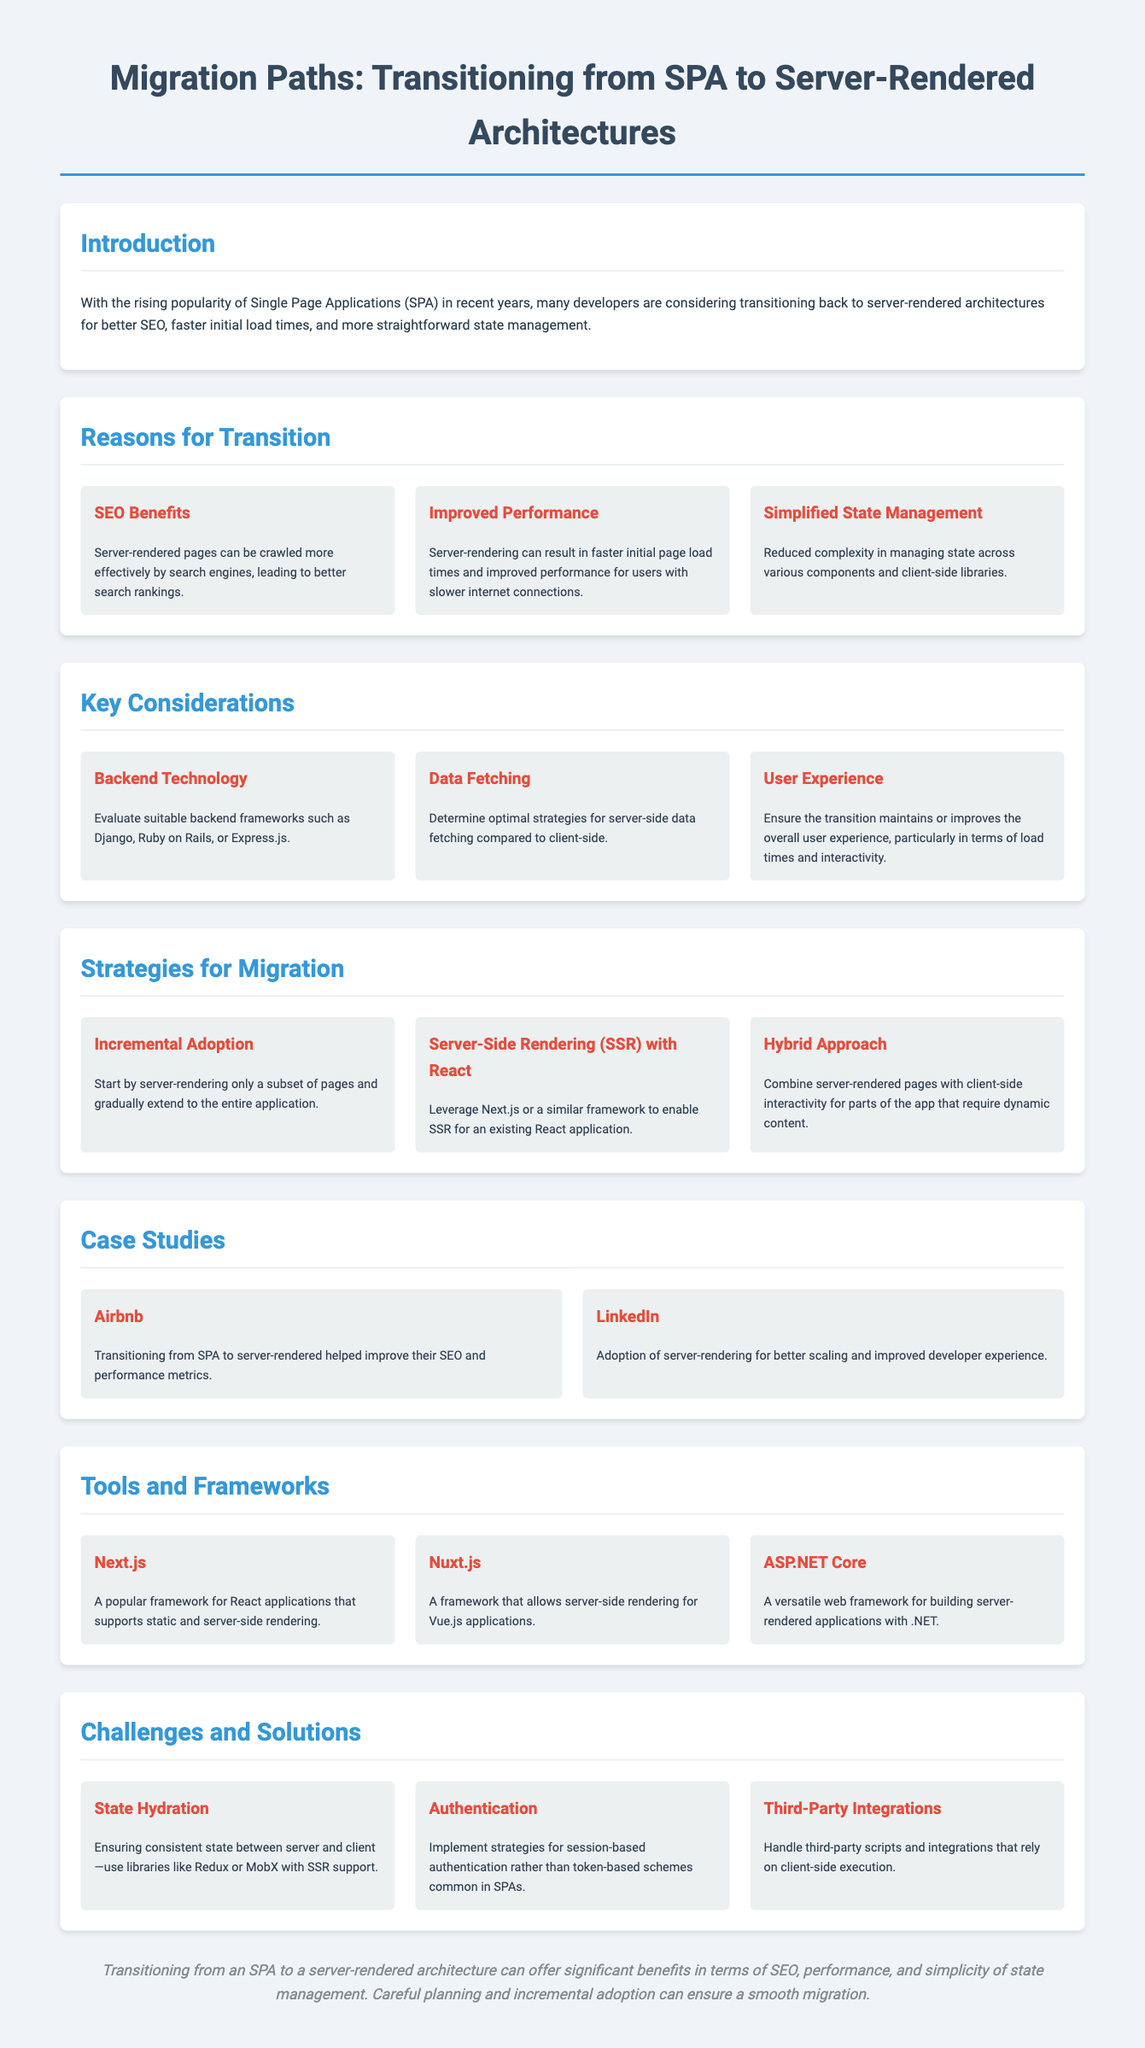What are the benefits of transitioning to server-rendered architectures? The document outlines key reasons for transitioning to server-rendered architectures including SEO benefits, improved performance, and simplified state management.
Answer: SEO benefits, improved performance, simplified state management Which frameworks are suggested for backend technology? The document mentions suitable backend frameworks such as Django, Ruby on Rails, and Express.js for consideration.
Answer: Django, Ruby on Rails, Express.js What is the first strategy for migration mentioned? The document states that starting with server-rendering a subset of pages and gradually extending to the entire application is the incremental adoption strategy.
Answer: Incremental Adoption Which company improved their SEO and performance metrics after transitioning? The document provides Airbnb as a case study where the transition resulted in improved SEO and performance metrics.
Answer: Airbnb What is a challenge related to transitioning from SPA to server-rendered architecture? The document lists state hydration, authentication, and third-party integrations as challenges when transitioning to server-rendered architectures.
Answer: State Hydration Which framework is highlighted for React applications supporting server-side rendering? Next.js is mentioned in the document as a popular framework for React applications that supports static and server-side rendering.
Answer: Next.js What does SSR stand for in the context of the document? The acronym SSR refers to server-side rendering, a key concept in the migration strategies discussed in the document.
Answer: Server-Side Rendering What is the purpose of using libraries like Redux in the migration process? The document mentions using libraries like Redux or MobX to ensure consistent state between server and client during the migration to server-rendered architecture.
Answer: Consistent state What is the overall conclusion about transitioning from an SPA to server-rendered architecture? The conclusion emphasizes the significant benefits in terms of SEO, performance, and simplicity of state management when transitioning to server-rendered architecture.
Answer: Significant benefits 